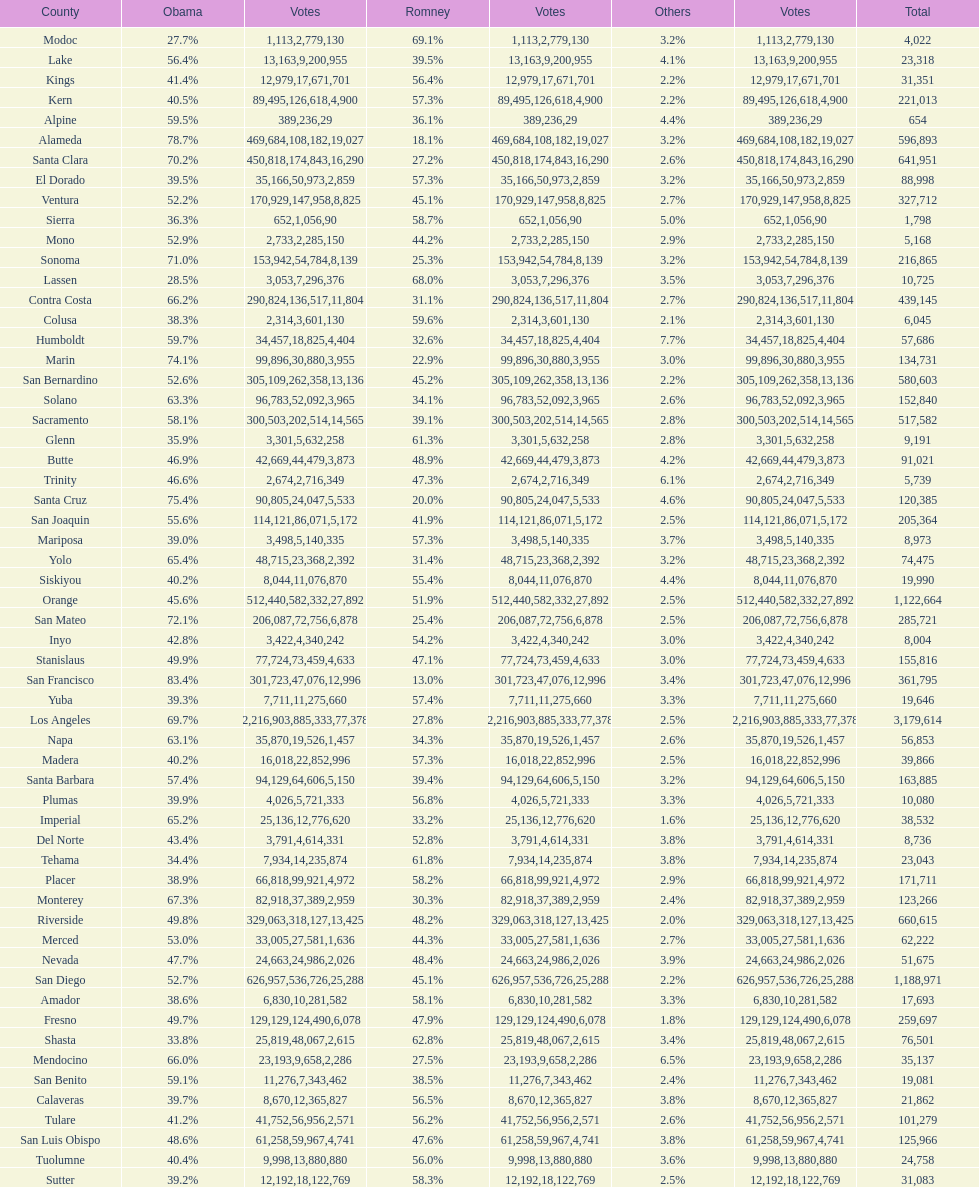Which count registered the minimum number of votes for obama? Modoc. 